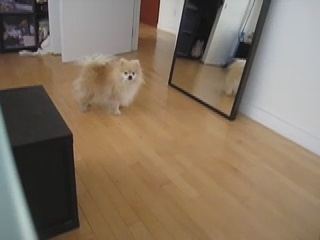Describe the objects in this image and their specific colors. I can see a dog in black, gray, tan, darkgray, and brown tones in this image. 